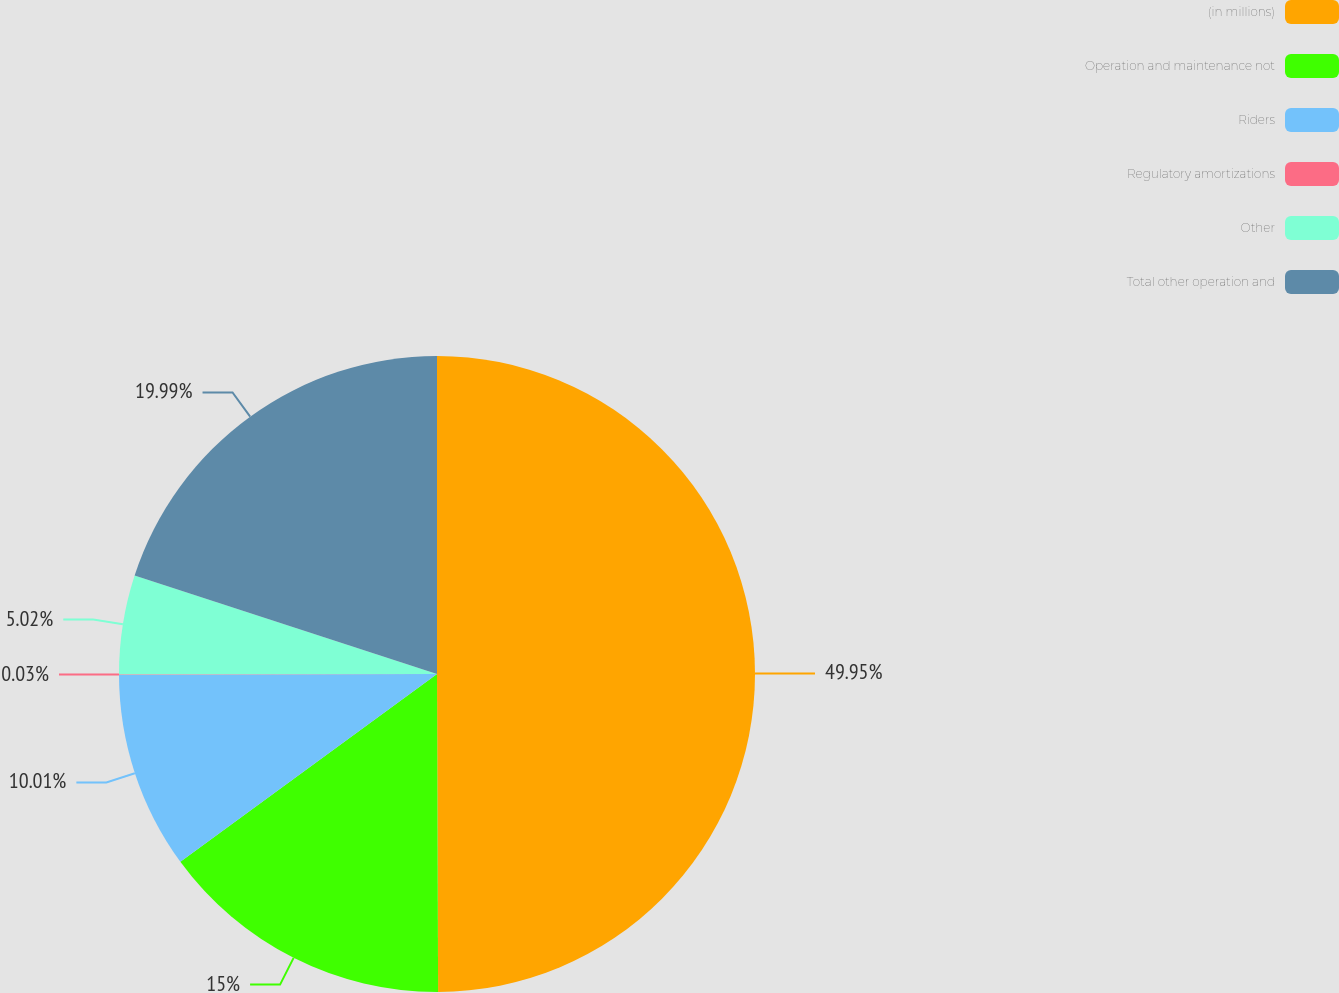Convert chart to OTSL. <chart><loc_0><loc_0><loc_500><loc_500><pie_chart><fcel>(in millions)<fcel>Operation and maintenance not<fcel>Riders<fcel>Regulatory amortizations<fcel>Other<fcel>Total other operation and<nl><fcel>49.94%<fcel>15.0%<fcel>10.01%<fcel>0.03%<fcel>5.02%<fcel>19.99%<nl></chart> 